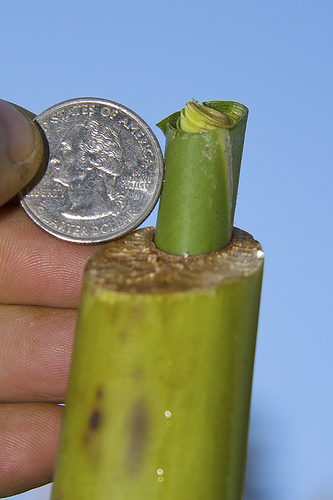<image>
Is the coin on the fingers? Yes. Looking at the image, I can see the coin is positioned on top of the fingers, with the fingers providing support. Where is the coin in relation to the plant? Is it next to the plant? Yes. The coin is positioned adjacent to the plant, located nearby in the same general area. 